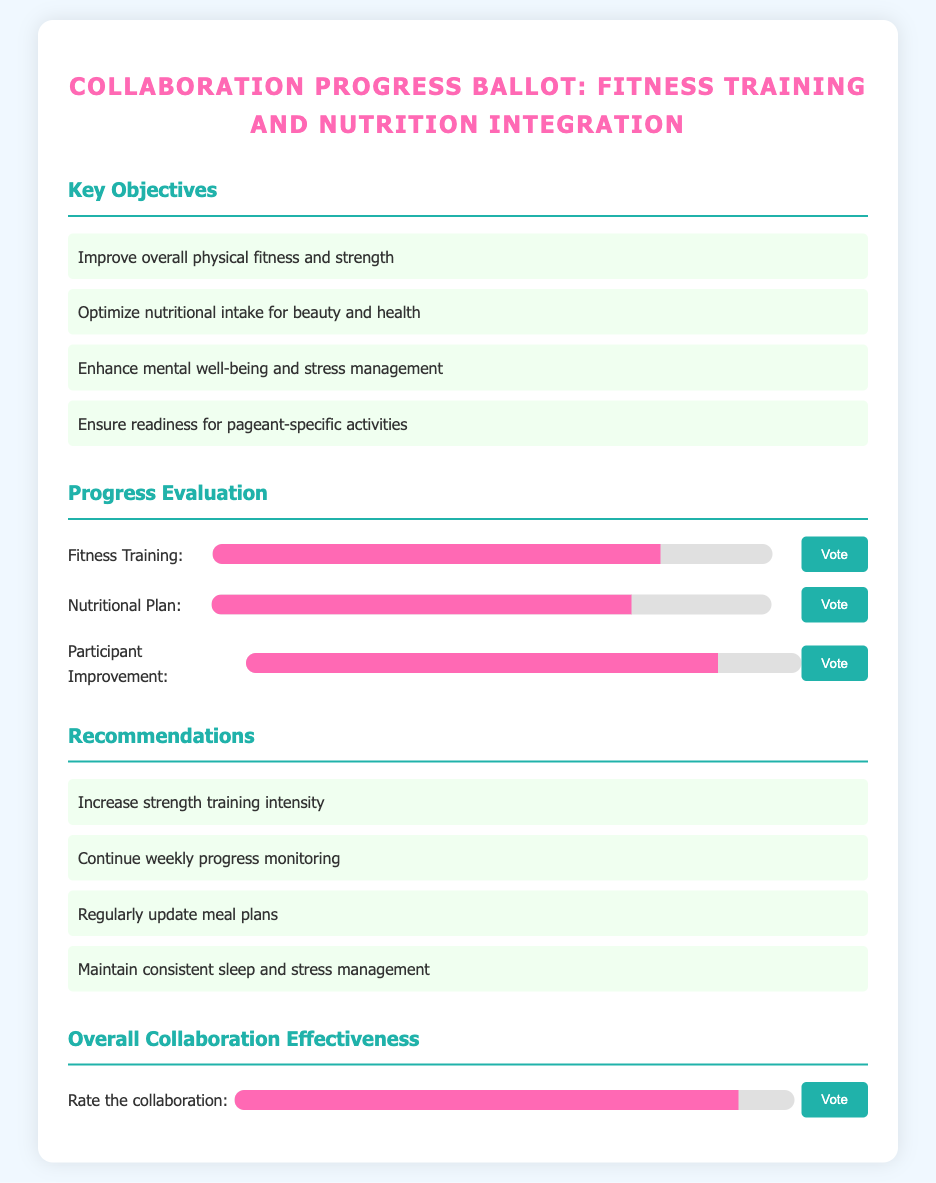what is the progress percentage for Fitness Training? The progress percentage for Fitness Training is indicated in the progress bar as 80%.
Answer: 80% what is the recommended action for the nutritional plan? The recommendations suggest regularly updating meal plans for optimal health.
Answer: Regularly update meal plans how effective is the overall collaboration rated? The document indicates the overall collaboration effectiveness, shown in the progress bar as 90%.
Answer: 90% what is the main objective related to mental well-being? The document states enhancing mental well-being and stress management as a key objective.
Answer: Enhance mental well-being and stress management what percentage reflects participant improvement? The progress bar shows participant improvement at 85%.
Answer: 85% which area has the highest progress percentage? The progress percentages for Fitness Training (80%), Nutritional Plan (75%), and Participant Improvement (85%) indicate that Participant Improvement has the highest percentage.
Answer: Participant Improvement how many key objectives are listed in the document? The number of key objectives listed in the document totals four.
Answer: 4 name an area that requires increased intensity according to recommendations. The recommendations explicitly mention increasing strength training intensity as an area for improvement.
Answer: Increase strength training intensity what is the background color of the ballot? The document specifies the background color of the ballot as white.
Answer: White 